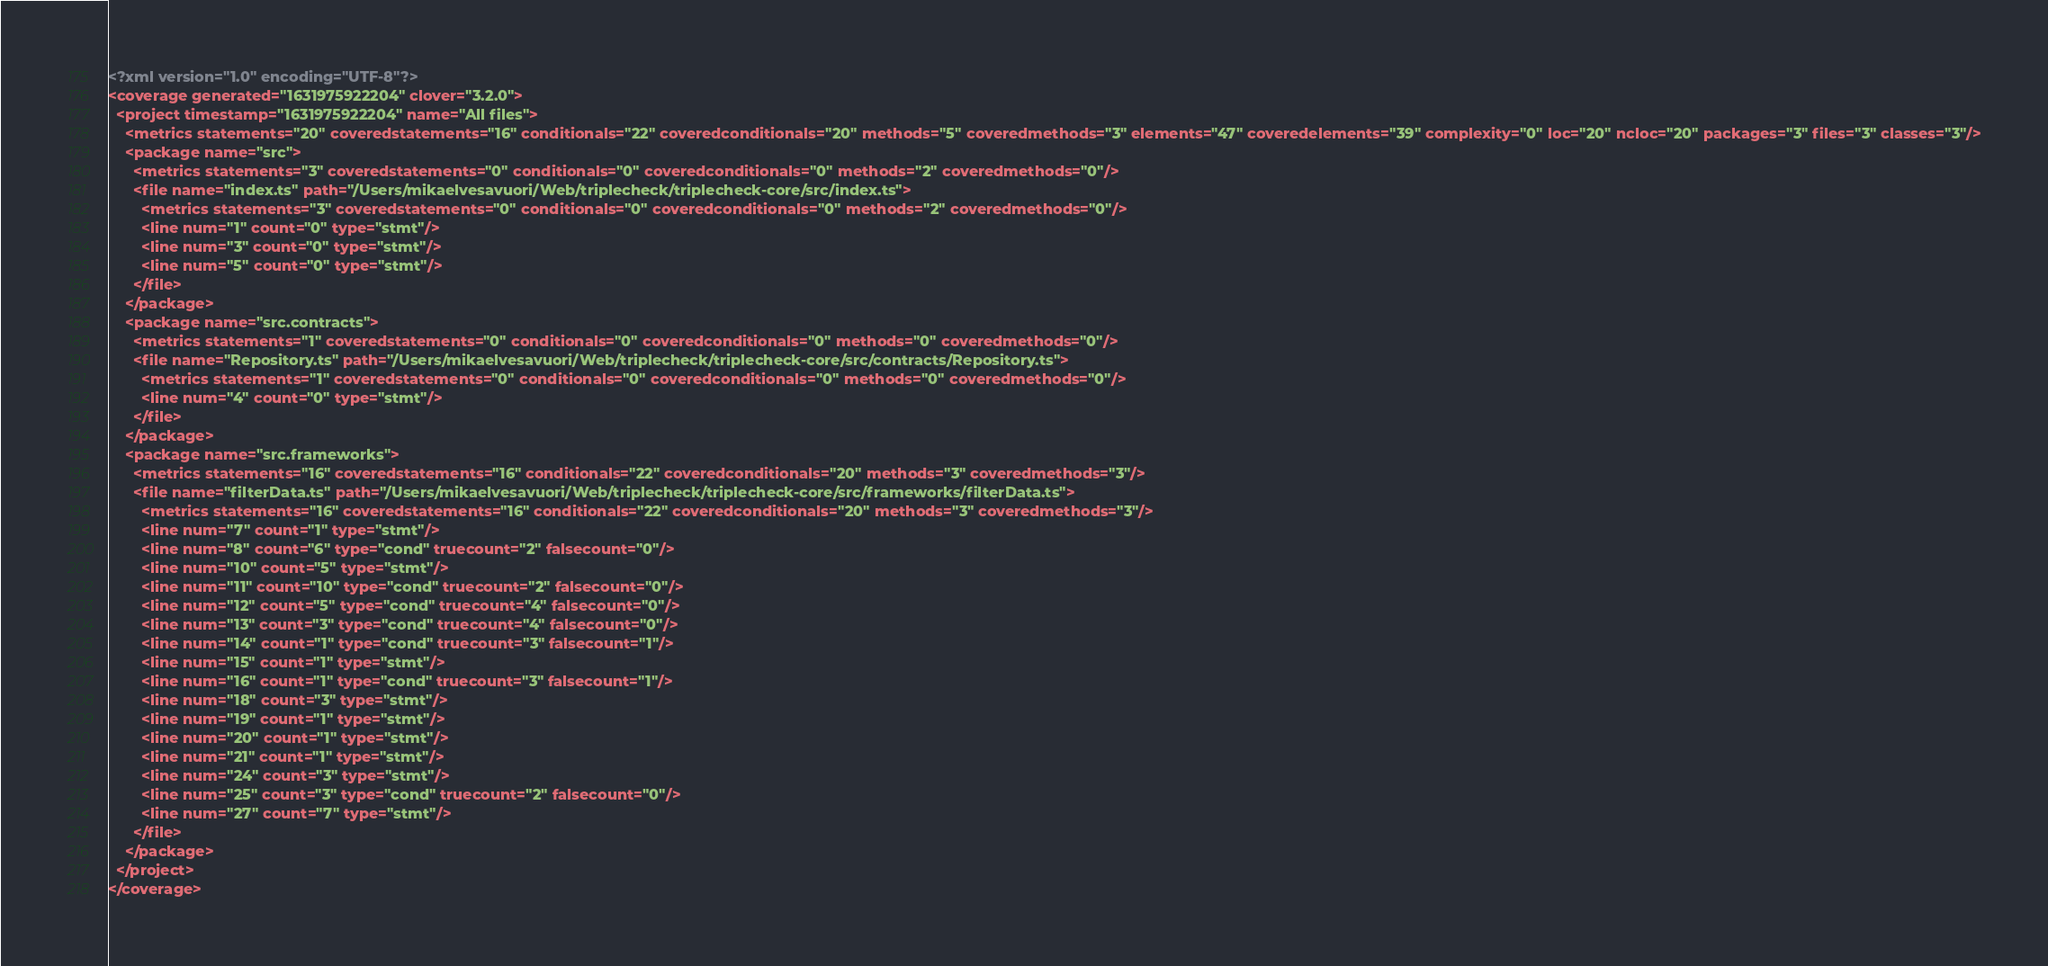<code> <loc_0><loc_0><loc_500><loc_500><_XML_><?xml version="1.0" encoding="UTF-8"?>
<coverage generated="1631975922204" clover="3.2.0">
  <project timestamp="1631975922204" name="All files">
    <metrics statements="20" coveredstatements="16" conditionals="22" coveredconditionals="20" methods="5" coveredmethods="3" elements="47" coveredelements="39" complexity="0" loc="20" ncloc="20" packages="3" files="3" classes="3"/>
    <package name="src">
      <metrics statements="3" coveredstatements="0" conditionals="0" coveredconditionals="0" methods="2" coveredmethods="0"/>
      <file name="index.ts" path="/Users/mikaelvesavuori/Web/triplecheck/triplecheck-core/src/index.ts">
        <metrics statements="3" coveredstatements="0" conditionals="0" coveredconditionals="0" methods="2" coveredmethods="0"/>
        <line num="1" count="0" type="stmt"/>
        <line num="3" count="0" type="stmt"/>
        <line num="5" count="0" type="stmt"/>
      </file>
    </package>
    <package name="src.contracts">
      <metrics statements="1" coveredstatements="0" conditionals="0" coveredconditionals="0" methods="0" coveredmethods="0"/>
      <file name="Repository.ts" path="/Users/mikaelvesavuori/Web/triplecheck/triplecheck-core/src/contracts/Repository.ts">
        <metrics statements="1" coveredstatements="0" conditionals="0" coveredconditionals="0" methods="0" coveredmethods="0"/>
        <line num="4" count="0" type="stmt"/>
      </file>
    </package>
    <package name="src.frameworks">
      <metrics statements="16" coveredstatements="16" conditionals="22" coveredconditionals="20" methods="3" coveredmethods="3"/>
      <file name="filterData.ts" path="/Users/mikaelvesavuori/Web/triplecheck/triplecheck-core/src/frameworks/filterData.ts">
        <metrics statements="16" coveredstatements="16" conditionals="22" coveredconditionals="20" methods="3" coveredmethods="3"/>
        <line num="7" count="1" type="stmt"/>
        <line num="8" count="6" type="cond" truecount="2" falsecount="0"/>
        <line num="10" count="5" type="stmt"/>
        <line num="11" count="10" type="cond" truecount="2" falsecount="0"/>
        <line num="12" count="5" type="cond" truecount="4" falsecount="0"/>
        <line num="13" count="3" type="cond" truecount="4" falsecount="0"/>
        <line num="14" count="1" type="cond" truecount="3" falsecount="1"/>
        <line num="15" count="1" type="stmt"/>
        <line num="16" count="1" type="cond" truecount="3" falsecount="1"/>
        <line num="18" count="3" type="stmt"/>
        <line num="19" count="1" type="stmt"/>
        <line num="20" count="1" type="stmt"/>
        <line num="21" count="1" type="stmt"/>
        <line num="24" count="3" type="stmt"/>
        <line num="25" count="3" type="cond" truecount="2" falsecount="0"/>
        <line num="27" count="7" type="stmt"/>
      </file>
    </package>
  </project>
</coverage>
</code> 